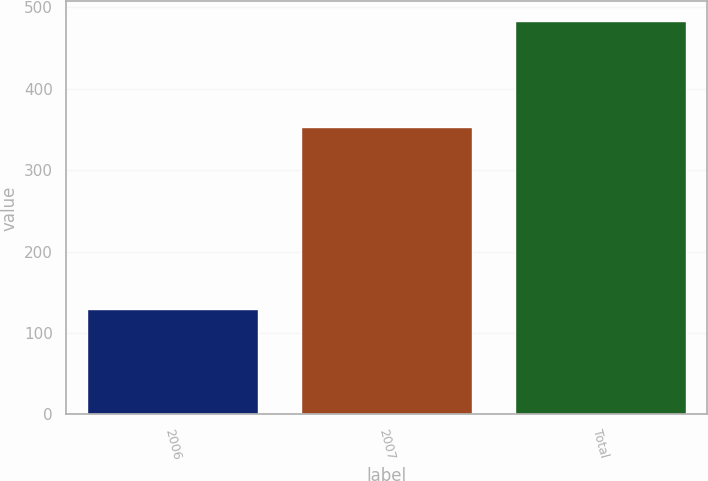Convert chart. <chart><loc_0><loc_0><loc_500><loc_500><bar_chart><fcel>2006<fcel>2007<fcel>Total<nl><fcel>130<fcel>353<fcel>483<nl></chart> 